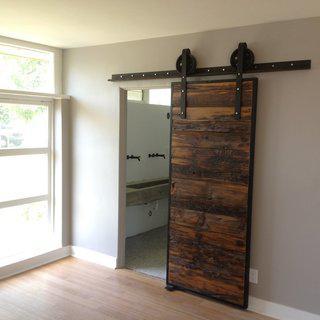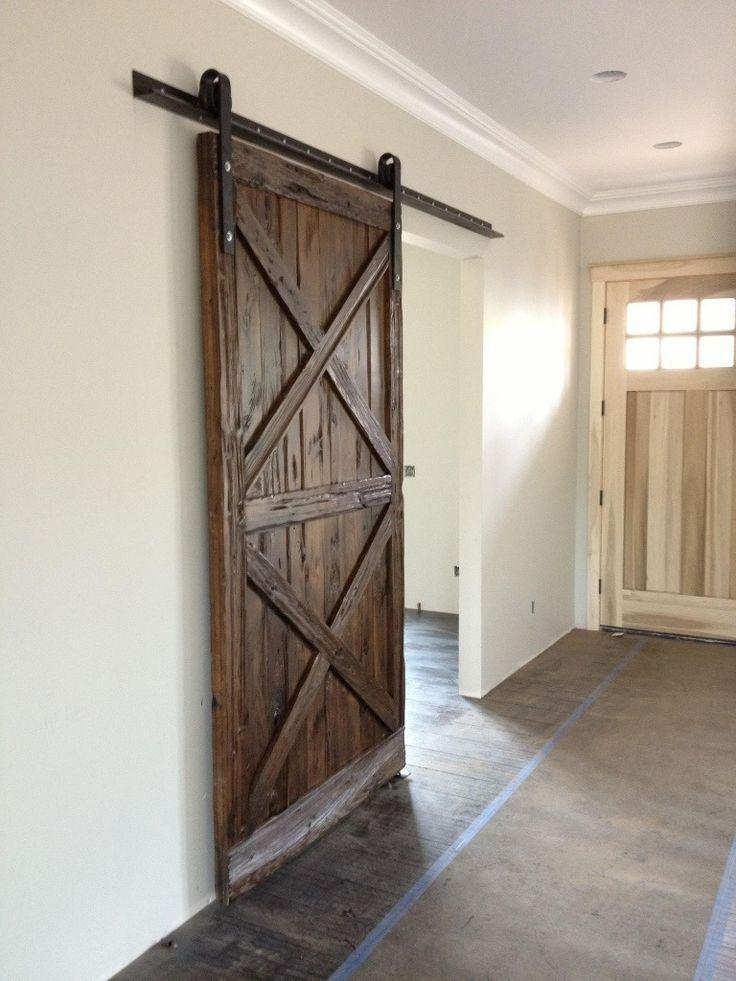The first image is the image on the left, the second image is the image on the right. Assess this claim about the two images: "The left image features a 'barn style' door made of weathered-look horizontal wood boards that slides on a black bar at the top.". Correct or not? Answer yes or no. Yes. The first image is the image on the left, the second image is the image on the right. Given the left and right images, does the statement "The left and right image contains the same number of hanging doors." hold true? Answer yes or no. Yes. 